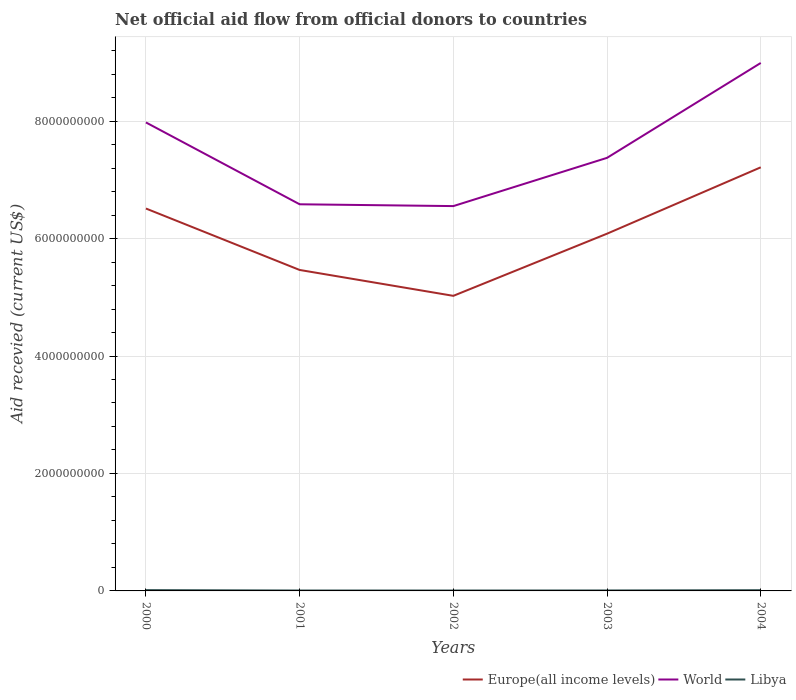Across all years, what is the maximum total aid received in Libya?
Provide a short and direct response. 6.88e+06. What is the total total aid received in World in the graph?
Offer a terse response. -2.41e+09. What is the difference between the highest and the second highest total aid received in Libya?
Your response must be concise. 6.87e+06. What is the difference between the highest and the lowest total aid received in Libya?
Your answer should be compact. 2. How many lines are there?
Offer a terse response. 3. How many years are there in the graph?
Provide a short and direct response. 5. What is the difference between two consecutive major ticks on the Y-axis?
Make the answer very short. 2.00e+09. Does the graph contain any zero values?
Offer a very short reply. No. Does the graph contain grids?
Offer a terse response. Yes. Where does the legend appear in the graph?
Give a very brief answer. Bottom right. What is the title of the graph?
Offer a terse response. Net official aid flow from official donors to countries. Does "Solomon Islands" appear as one of the legend labels in the graph?
Ensure brevity in your answer.  No. What is the label or title of the X-axis?
Your answer should be very brief. Years. What is the label or title of the Y-axis?
Make the answer very short. Aid recevied (current US$). What is the Aid recevied (current US$) in Europe(all income levels) in 2000?
Offer a terse response. 6.51e+09. What is the Aid recevied (current US$) of World in 2000?
Offer a terse response. 7.98e+09. What is the Aid recevied (current US$) in Libya in 2000?
Provide a short and direct response. 1.38e+07. What is the Aid recevied (current US$) in Europe(all income levels) in 2001?
Keep it short and to the point. 5.47e+09. What is the Aid recevied (current US$) in World in 2001?
Keep it short and to the point. 6.58e+09. What is the Aid recevied (current US$) of Libya in 2001?
Your answer should be compact. 7.14e+06. What is the Aid recevied (current US$) in Europe(all income levels) in 2002?
Offer a very short reply. 5.02e+09. What is the Aid recevied (current US$) in World in 2002?
Offer a terse response. 6.55e+09. What is the Aid recevied (current US$) in Libya in 2002?
Your answer should be compact. 6.88e+06. What is the Aid recevied (current US$) of Europe(all income levels) in 2003?
Your response must be concise. 6.08e+09. What is the Aid recevied (current US$) of World in 2003?
Make the answer very short. 7.37e+09. What is the Aid recevied (current US$) in Libya in 2003?
Give a very brief answer. 7.95e+06. What is the Aid recevied (current US$) of Europe(all income levels) in 2004?
Provide a succinct answer. 7.21e+09. What is the Aid recevied (current US$) of World in 2004?
Offer a terse response. 8.99e+09. What is the Aid recevied (current US$) in Libya in 2004?
Provide a short and direct response. 1.24e+07. Across all years, what is the maximum Aid recevied (current US$) of Europe(all income levels)?
Your answer should be very brief. 7.21e+09. Across all years, what is the maximum Aid recevied (current US$) of World?
Your answer should be very brief. 8.99e+09. Across all years, what is the maximum Aid recevied (current US$) of Libya?
Your answer should be very brief. 1.38e+07. Across all years, what is the minimum Aid recevied (current US$) in Europe(all income levels)?
Offer a terse response. 5.02e+09. Across all years, what is the minimum Aid recevied (current US$) of World?
Provide a short and direct response. 6.55e+09. Across all years, what is the minimum Aid recevied (current US$) in Libya?
Your response must be concise. 6.88e+06. What is the total Aid recevied (current US$) of Europe(all income levels) in the graph?
Your answer should be very brief. 3.03e+1. What is the total Aid recevied (current US$) in World in the graph?
Ensure brevity in your answer.  3.75e+1. What is the total Aid recevied (current US$) in Libya in the graph?
Give a very brief answer. 4.82e+07. What is the difference between the Aid recevied (current US$) of Europe(all income levels) in 2000 and that in 2001?
Give a very brief answer. 1.05e+09. What is the difference between the Aid recevied (current US$) in World in 2000 and that in 2001?
Your response must be concise. 1.39e+09. What is the difference between the Aid recevied (current US$) in Libya in 2000 and that in 2001?
Offer a very short reply. 6.61e+06. What is the difference between the Aid recevied (current US$) of Europe(all income levels) in 2000 and that in 2002?
Make the answer very short. 1.49e+09. What is the difference between the Aid recevied (current US$) of World in 2000 and that in 2002?
Provide a succinct answer. 1.42e+09. What is the difference between the Aid recevied (current US$) of Libya in 2000 and that in 2002?
Give a very brief answer. 6.87e+06. What is the difference between the Aid recevied (current US$) in Europe(all income levels) in 2000 and that in 2003?
Provide a short and direct response. 4.28e+08. What is the difference between the Aid recevied (current US$) in World in 2000 and that in 2003?
Provide a succinct answer. 6.03e+08. What is the difference between the Aid recevied (current US$) of Libya in 2000 and that in 2003?
Your answer should be very brief. 5.80e+06. What is the difference between the Aid recevied (current US$) in Europe(all income levels) in 2000 and that in 2004?
Your answer should be compact. -7.02e+08. What is the difference between the Aid recevied (current US$) of World in 2000 and that in 2004?
Keep it short and to the point. -1.01e+09. What is the difference between the Aid recevied (current US$) of Libya in 2000 and that in 2004?
Your answer should be compact. 1.32e+06. What is the difference between the Aid recevied (current US$) in Europe(all income levels) in 2001 and that in 2002?
Your response must be concise. 4.41e+08. What is the difference between the Aid recevied (current US$) of World in 2001 and that in 2002?
Provide a succinct answer. 3.09e+07. What is the difference between the Aid recevied (current US$) in Libya in 2001 and that in 2002?
Keep it short and to the point. 2.60e+05. What is the difference between the Aid recevied (current US$) of Europe(all income levels) in 2001 and that in 2003?
Give a very brief answer. -6.18e+08. What is the difference between the Aid recevied (current US$) of World in 2001 and that in 2003?
Provide a succinct answer. -7.91e+08. What is the difference between the Aid recevied (current US$) of Libya in 2001 and that in 2003?
Ensure brevity in your answer.  -8.10e+05. What is the difference between the Aid recevied (current US$) in Europe(all income levels) in 2001 and that in 2004?
Give a very brief answer. -1.75e+09. What is the difference between the Aid recevied (current US$) in World in 2001 and that in 2004?
Keep it short and to the point. -2.41e+09. What is the difference between the Aid recevied (current US$) of Libya in 2001 and that in 2004?
Ensure brevity in your answer.  -5.29e+06. What is the difference between the Aid recevied (current US$) in Europe(all income levels) in 2002 and that in 2003?
Provide a succinct answer. -1.06e+09. What is the difference between the Aid recevied (current US$) of World in 2002 and that in 2003?
Offer a terse response. -8.22e+08. What is the difference between the Aid recevied (current US$) in Libya in 2002 and that in 2003?
Provide a short and direct response. -1.07e+06. What is the difference between the Aid recevied (current US$) of Europe(all income levels) in 2002 and that in 2004?
Offer a very short reply. -2.19e+09. What is the difference between the Aid recevied (current US$) of World in 2002 and that in 2004?
Make the answer very short. -2.44e+09. What is the difference between the Aid recevied (current US$) in Libya in 2002 and that in 2004?
Your response must be concise. -5.55e+06. What is the difference between the Aid recevied (current US$) of Europe(all income levels) in 2003 and that in 2004?
Offer a terse response. -1.13e+09. What is the difference between the Aid recevied (current US$) of World in 2003 and that in 2004?
Provide a succinct answer. -1.62e+09. What is the difference between the Aid recevied (current US$) in Libya in 2003 and that in 2004?
Provide a short and direct response. -4.48e+06. What is the difference between the Aid recevied (current US$) in Europe(all income levels) in 2000 and the Aid recevied (current US$) in World in 2001?
Your answer should be compact. -7.22e+07. What is the difference between the Aid recevied (current US$) in Europe(all income levels) in 2000 and the Aid recevied (current US$) in Libya in 2001?
Provide a succinct answer. 6.50e+09. What is the difference between the Aid recevied (current US$) in World in 2000 and the Aid recevied (current US$) in Libya in 2001?
Offer a terse response. 7.97e+09. What is the difference between the Aid recevied (current US$) of Europe(all income levels) in 2000 and the Aid recevied (current US$) of World in 2002?
Offer a very short reply. -4.13e+07. What is the difference between the Aid recevied (current US$) of Europe(all income levels) in 2000 and the Aid recevied (current US$) of Libya in 2002?
Ensure brevity in your answer.  6.50e+09. What is the difference between the Aid recevied (current US$) in World in 2000 and the Aid recevied (current US$) in Libya in 2002?
Offer a terse response. 7.97e+09. What is the difference between the Aid recevied (current US$) in Europe(all income levels) in 2000 and the Aid recevied (current US$) in World in 2003?
Provide a short and direct response. -8.63e+08. What is the difference between the Aid recevied (current US$) in Europe(all income levels) in 2000 and the Aid recevied (current US$) in Libya in 2003?
Give a very brief answer. 6.50e+09. What is the difference between the Aid recevied (current US$) in World in 2000 and the Aid recevied (current US$) in Libya in 2003?
Your answer should be compact. 7.97e+09. What is the difference between the Aid recevied (current US$) of Europe(all income levels) in 2000 and the Aid recevied (current US$) of World in 2004?
Offer a terse response. -2.48e+09. What is the difference between the Aid recevied (current US$) of Europe(all income levels) in 2000 and the Aid recevied (current US$) of Libya in 2004?
Provide a succinct answer. 6.50e+09. What is the difference between the Aid recevied (current US$) of World in 2000 and the Aid recevied (current US$) of Libya in 2004?
Your response must be concise. 7.96e+09. What is the difference between the Aid recevied (current US$) of Europe(all income levels) in 2001 and the Aid recevied (current US$) of World in 2002?
Your answer should be compact. -1.09e+09. What is the difference between the Aid recevied (current US$) of Europe(all income levels) in 2001 and the Aid recevied (current US$) of Libya in 2002?
Your response must be concise. 5.46e+09. What is the difference between the Aid recevied (current US$) in World in 2001 and the Aid recevied (current US$) in Libya in 2002?
Keep it short and to the point. 6.58e+09. What is the difference between the Aid recevied (current US$) in Europe(all income levels) in 2001 and the Aid recevied (current US$) in World in 2003?
Your answer should be compact. -1.91e+09. What is the difference between the Aid recevied (current US$) in Europe(all income levels) in 2001 and the Aid recevied (current US$) in Libya in 2003?
Give a very brief answer. 5.46e+09. What is the difference between the Aid recevied (current US$) in World in 2001 and the Aid recevied (current US$) in Libya in 2003?
Provide a short and direct response. 6.58e+09. What is the difference between the Aid recevied (current US$) of Europe(all income levels) in 2001 and the Aid recevied (current US$) of World in 2004?
Provide a succinct answer. -3.52e+09. What is the difference between the Aid recevied (current US$) in Europe(all income levels) in 2001 and the Aid recevied (current US$) in Libya in 2004?
Your answer should be very brief. 5.45e+09. What is the difference between the Aid recevied (current US$) of World in 2001 and the Aid recevied (current US$) of Libya in 2004?
Provide a succinct answer. 6.57e+09. What is the difference between the Aid recevied (current US$) of Europe(all income levels) in 2002 and the Aid recevied (current US$) of World in 2003?
Provide a succinct answer. -2.35e+09. What is the difference between the Aid recevied (current US$) of Europe(all income levels) in 2002 and the Aid recevied (current US$) of Libya in 2003?
Give a very brief answer. 5.02e+09. What is the difference between the Aid recevied (current US$) in World in 2002 and the Aid recevied (current US$) in Libya in 2003?
Your answer should be compact. 6.54e+09. What is the difference between the Aid recevied (current US$) in Europe(all income levels) in 2002 and the Aid recevied (current US$) in World in 2004?
Make the answer very short. -3.97e+09. What is the difference between the Aid recevied (current US$) in Europe(all income levels) in 2002 and the Aid recevied (current US$) in Libya in 2004?
Provide a short and direct response. 5.01e+09. What is the difference between the Aid recevied (current US$) in World in 2002 and the Aid recevied (current US$) in Libya in 2004?
Provide a short and direct response. 6.54e+09. What is the difference between the Aid recevied (current US$) of Europe(all income levels) in 2003 and the Aid recevied (current US$) of World in 2004?
Keep it short and to the point. -2.91e+09. What is the difference between the Aid recevied (current US$) in Europe(all income levels) in 2003 and the Aid recevied (current US$) in Libya in 2004?
Your response must be concise. 6.07e+09. What is the difference between the Aid recevied (current US$) of World in 2003 and the Aid recevied (current US$) of Libya in 2004?
Your response must be concise. 7.36e+09. What is the average Aid recevied (current US$) of Europe(all income levels) per year?
Your response must be concise. 6.06e+09. What is the average Aid recevied (current US$) of World per year?
Give a very brief answer. 7.50e+09. What is the average Aid recevied (current US$) of Libya per year?
Your answer should be very brief. 9.63e+06. In the year 2000, what is the difference between the Aid recevied (current US$) of Europe(all income levels) and Aid recevied (current US$) of World?
Ensure brevity in your answer.  -1.47e+09. In the year 2000, what is the difference between the Aid recevied (current US$) of Europe(all income levels) and Aid recevied (current US$) of Libya?
Offer a very short reply. 6.50e+09. In the year 2000, what is the difference between the Aid recevied (current US$) of World and Aid recevied (current US$) of Libya?
Offer a very short reply. 7.96e+09. In the year 2001, what is the difference between the Aid recevied (current US$) of Europe(all income levels) and Aid recevied (current US$) of World?
Your response must be concise. -1.12e+09. In the year 2001, what is the difference between the Aid recevied (current US$) in Europe(all income levels) and Aid recevied (current US$) in Libya?
Offer a very short reply. 5.46e+09. In the year 2001, what is the difference between the Aid recevied (current US$) of World and Aid recevied (current US$) of Libya?
Keep it short and to the point. 6.58e+09. In the year 2002, what is the difference between the Aid recevied (current US$) in Europe(all income levels) and Aid recevied (current US$) in World?
Provide a short and direct response. -1.53e+09. In the year 2002, what is the difference between the Aid recevied (current US$) in Europe(all income levels) and Aid recevied (current US$) in Libya?
Give a very brief answer. 5.02e+09. In the year 2002, what is the difference between the Aid recevied (current US$) in World and Aid recevied (current US$) in Libya?
Offer a very short reply. 6.55e+09. In the year 2003, what is the difference between the Aid recevied (current US$) in Europe(all income levels) and Aid recevied (current US$) in World?
Offer a terse response. -1.29e+09. In the year 2003, what is the difference between the Aid recevied (current US$) of Europe(all income levels) and Aid recevied (current US$) of Libya?
Make the answer very short. 6.08e+09. In the year 2003, what is the difference between the Aid recevied (current US$) in World and Aid recevied (current US$) in Libya?
Your response must be concise. 7.37e+09. In the year 2004, what is the difference between the Aid recevied (current US$) in Europe(all income levels) and Aid recevied (current US$) in World?
Your answer should be very brief. -1.78e+09. In the year 2004, what is the difference between the Aid recevied (current US$) of Europe(all income levels) and Aid recevied (current US$) of Libya?
Offer a terse response. 7.20e+09. In the year 2004, what is the difference between the Aid recevied (current US$) of World and Aid recevied (current US$) of Libya?
Your answer should be compact. 8.98e+09. What is the ratio of the Aid recevied (current US$) of Europe(all income levels) in 2000 to that in 2001?
Provide a succinct answer. 1.19. What is the ratio of the Aid recevied (current US$) in World in 2000 to that in 2001?
Offer a very short reply. 1.21. What is the ratio of the Aid recevied (current US$) in Libya in 2000 to that in 2001?
Your answer should be compact. 1.93. What is the ratio of the Aid recevied (current US$) of Europe(all income levels) in 2000 to that in 2002?
Your answer should be compact. 1.3. What is the ratio of the Aid recevied (current US$) in World in 2000 to that in 2002?
Offer a terse response. 1.22. What is the ratio of the Aid recevied (current US$) of Libya in 2000 to that in 2002?
Provide a succinct answer. 2. What is the ratio of the Aid recevied (current US$) in Europe(all income levels) in 2000 to that in 2003?
Provide a succinct answer. 1.07. What is the ratio of the Aid recevied (current US$) in World in 2000 to that in 2003?
Your answer should be compact. 1.08. What is the ratio of the Aid recevied (current US$) in Libya in 2000 to that in 2003?
Offer a very short reply. 1.73. What is the ratio of the Aid recevied (current US$) in Europe(all income levels) in 2000 to that in 2004?
Give a very brief answer. 0.9. What is the ratio of the Aid recevied (current US$) in World in 2000 to that in 2004?
Your answer should be very brief. 0.89. What is the ratio of the Aid recevied (current US$) in Libya in 2000 to that in 2004?
Offer a terse response. 1.11. What is the ratio of the Aid recevied (current US$) in Europe(all income levels) in 2001 to that in 2002?
Make the answer very short. 1.09. What is the ratio of the Aid recevied (current US$) of World in 2001 to that in 2002?
Offer a very short reply. 1. What is the ratio of the Aid recevied (current US$) in Libya in 2001 to that in 2002?
Provide a succinct answer. 1.04. What is the ratio of the Aid recevied (current US$) in Europe(all income levels) in 2001 to that in 2003?
Ensure brevity in your answer.  0.9. What is the ratio of the Aid recevied (current US$) of World in 2001 to that in 2003?
Ensure brevity in your answer.  0.89. What is the ratio of the Aid recevied (current US$) in Libya in 2001 to that in 2003?
Keep it short and to the point. 0.9. What is the ratio of the Aid recevied (current US$) of Europe(all income levels) in 2001 to that in 2004?
Offer a very short reply. 0.76. What is the ratio of the Aid recevied (current US$) in World in 2001 to that in 2004?
Your answer should be very brief. 0.73. What is the ratio of the Aid recevied (current US$) of Libya in 2001 to that in 2004?
Your response must be concise. 0.57. What is the ratio of the Aid recevied (current US$) of Europe(all income levels) in 2002 to that in 2003?
Provide a succinct answer. 0.83. What is the ratio of the Aid recevied (current US$) of World in 2002 to that in 2003?
Your answer should be very brief. 0.89. What is the ratio of the Aid recevied (current US$) in Libya in 2002 to that in 2003?
Ensure brevity in your answer.  0.87. What is the ratio of the Aid recevied (current US$) of Europe(all income levels) in 2002 to that in 2004?
Give a very brief answer. 0.7. What is the ratio of the Aid recevied (current US$) in World in 2002 to that in 2004?
Offer a very short reply. 0.73. What is the ratio of the Aid recevied (current US$) of Libya in 2002 to that in 2004?
Make the answer very short. 0.55. What is the ratio of the Aid recevied (current US$) of Europe(all income levels) in 2003 to that in 2004?
Your answer should be compact. 0.84. What is the ratio of the Aid recevied (current US$) of World in 2003 to that in 2004?
Offer a terse response. 0.82. What is the ratio of the Aid recevied (current US$) in Libya in 2003 to that in 2004?
Your answer should be very brief. 0.64. What is the difference between the highest and the second highest Aid recevied (current US$) of Europe(all income levels)?
Give a very brief answer. 7.02e+08. What is the difference between the highest and the second highest Aid recevied (current US$) in World?
Make the answer very short. 1.01e+09. What is the difference between the highest and the second highest Aid recevied (current US$) in Libya?
Your answer should be compact. 1.32e+06. What is the difference between the highest and the lowest Aid recevied (current US$) of Europe(all income levels)?
Give a very brief answer. 2.19e+09. What is the difference between the highest and the lowest Aid recevied (current US$) of World?
Provide a short and direct response. 2.44e+09. What is the difference between the highest and the lowest Aid recevied (current US$) of Libya?
Keep it short and to the point. 6.87e+06. 